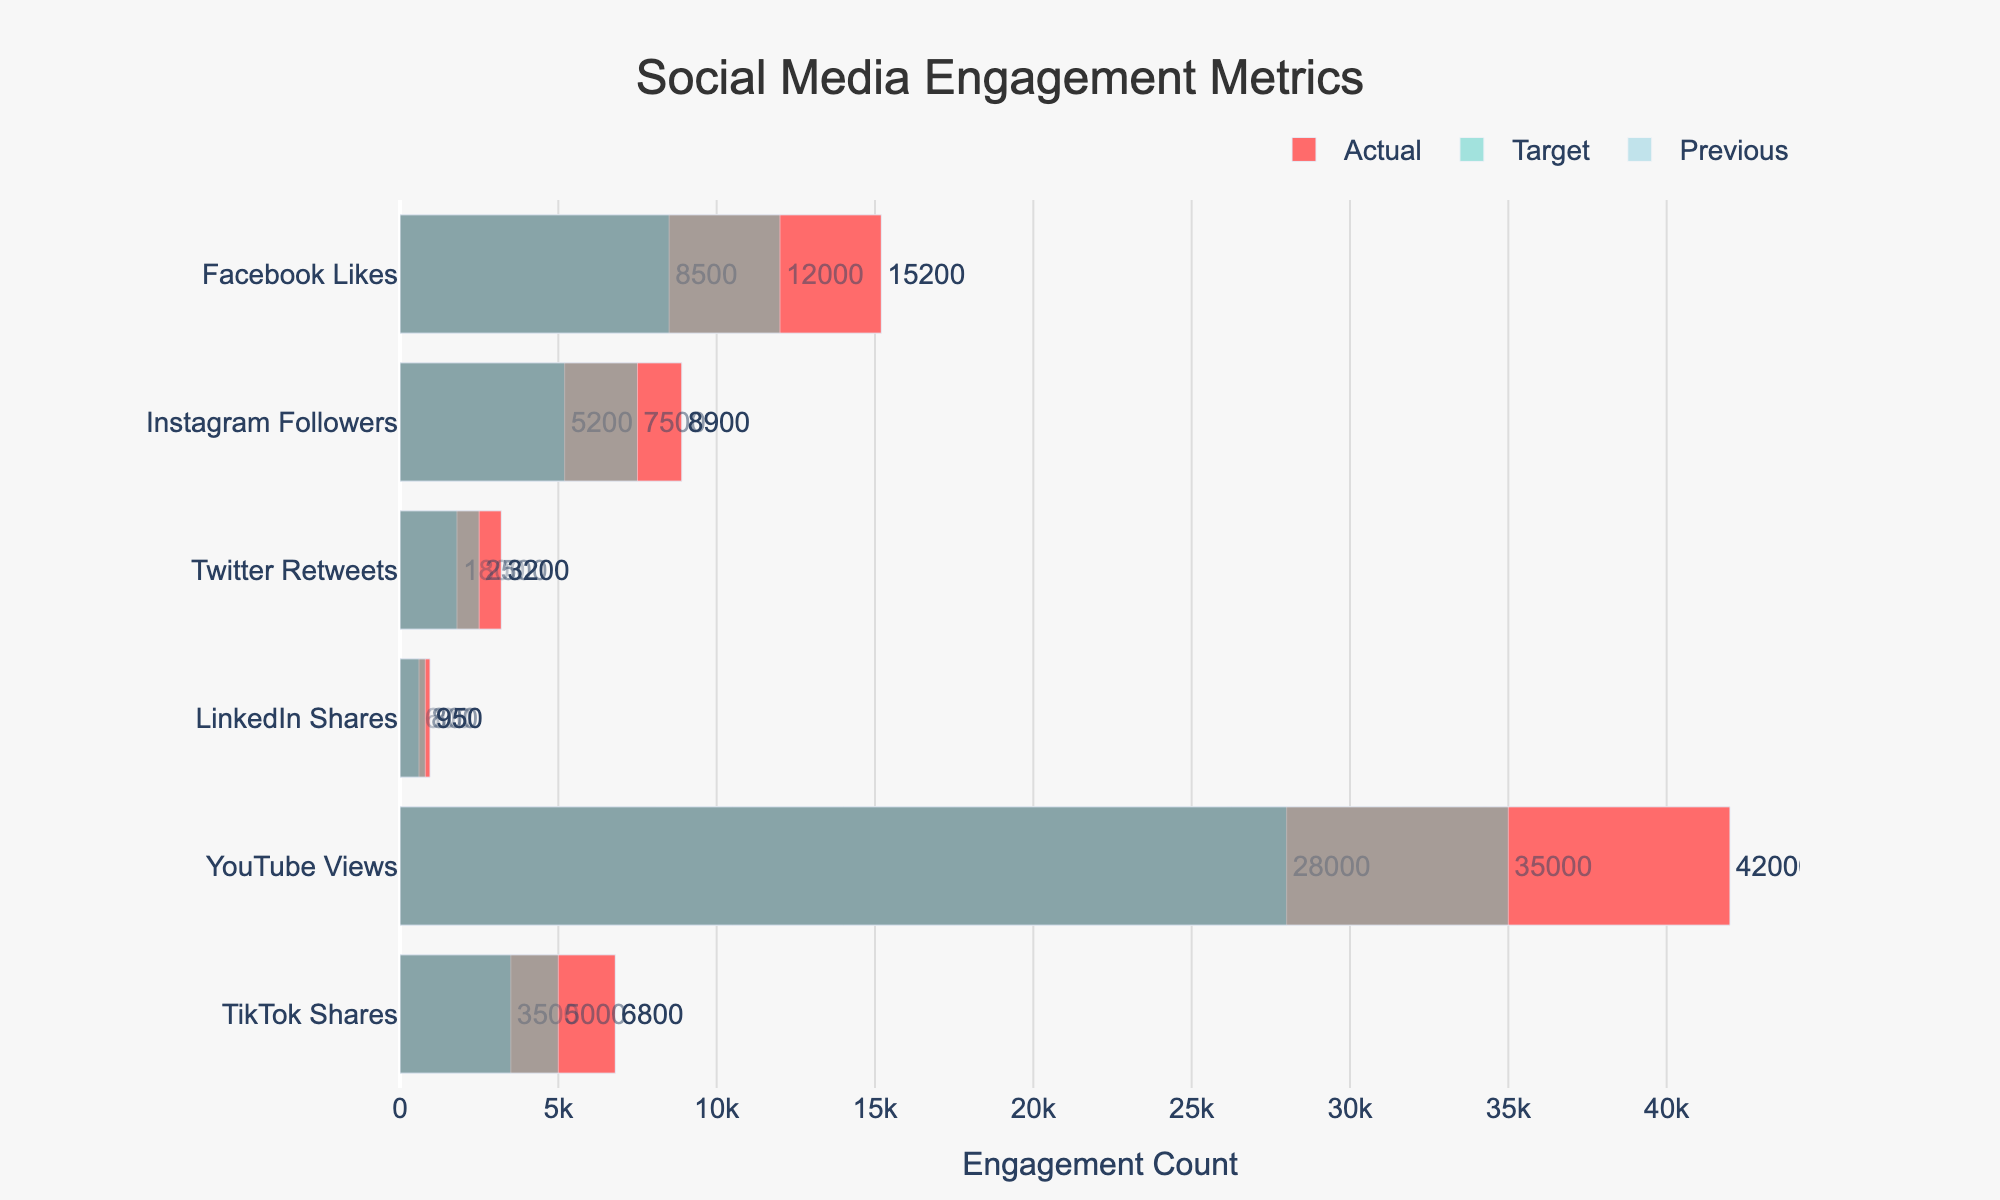What is the title of the plot? The title of the plot is located at the top center and reads 'Social Media Engagement Metrics'.
Answer: Social Media Engagement Metrics What is the engagement count for YouTube Views? You can see the actual engagement count for YouTube Views as the last bar on the y-axis. It's displayed outside the bar.
Answer: 42,000 Which metric exceeded its target by the largest amount? To find which metric exceeded its target by the largest amount, we look at the difference between the actual and target values for each metric. The largest difference is for YouTube Views (42,000 - 35,000 = 7,000).
Answer: YouTube Views How did the TikTok Shares actual engagement compare to its previous engagement? To answer this, compare the TikTok Shares' actual value to the previous value. The actual value is 6,800 and the previous is 3,500, showing an increase.
Answer: Increased Which social media metric showed the lowest engagement in the previous marketing efforts? Comparing the previous engagement values for all metrics, the lowest number is for LinkedIn Shares, which is 600.
Answer: LinkedIn Shares By how much did the Instagram Followers exceed their target? Refer to the Instagram Followers' actual and target values and compute the difference: 8,900 (actual) - 7,500 (target) = 1,400.
Answer: 1,400 Did any social media metric's actual engagement fall below its target? By inspecting all actual and target values in the plot, none of the actual values are lower than the target values for each metric.
Answer: No Which metrics doubled their previous engagement? To find out which metrics doubled their previous engagement, check the ratio of actual to previous values: Facebook Likes, Instagram Followers, Twitter Retweets, LinkedIn Shares, and TikTok Shares all more than doubled their previous engagements.
Answer: Facebook Likes, Instagram Followers, Twitter Retweets, LinkedIn Shares, TikTok Shares What is the previous engagement count for LinkedIn Shares? The previous value for LinkedIn Shares is found in the corresponding bar on the y-axis marked as 'Previous'. This value is 600.
Answer: 600 Which metric had the smallest increase from target to actual? To determine this, calculate the differences between actual and target values for each metric and find the smallest one. LinkedIn Shares' increase is 950 - 800 = 150, which is the smallest.
Answer: LinkedIn Shares 